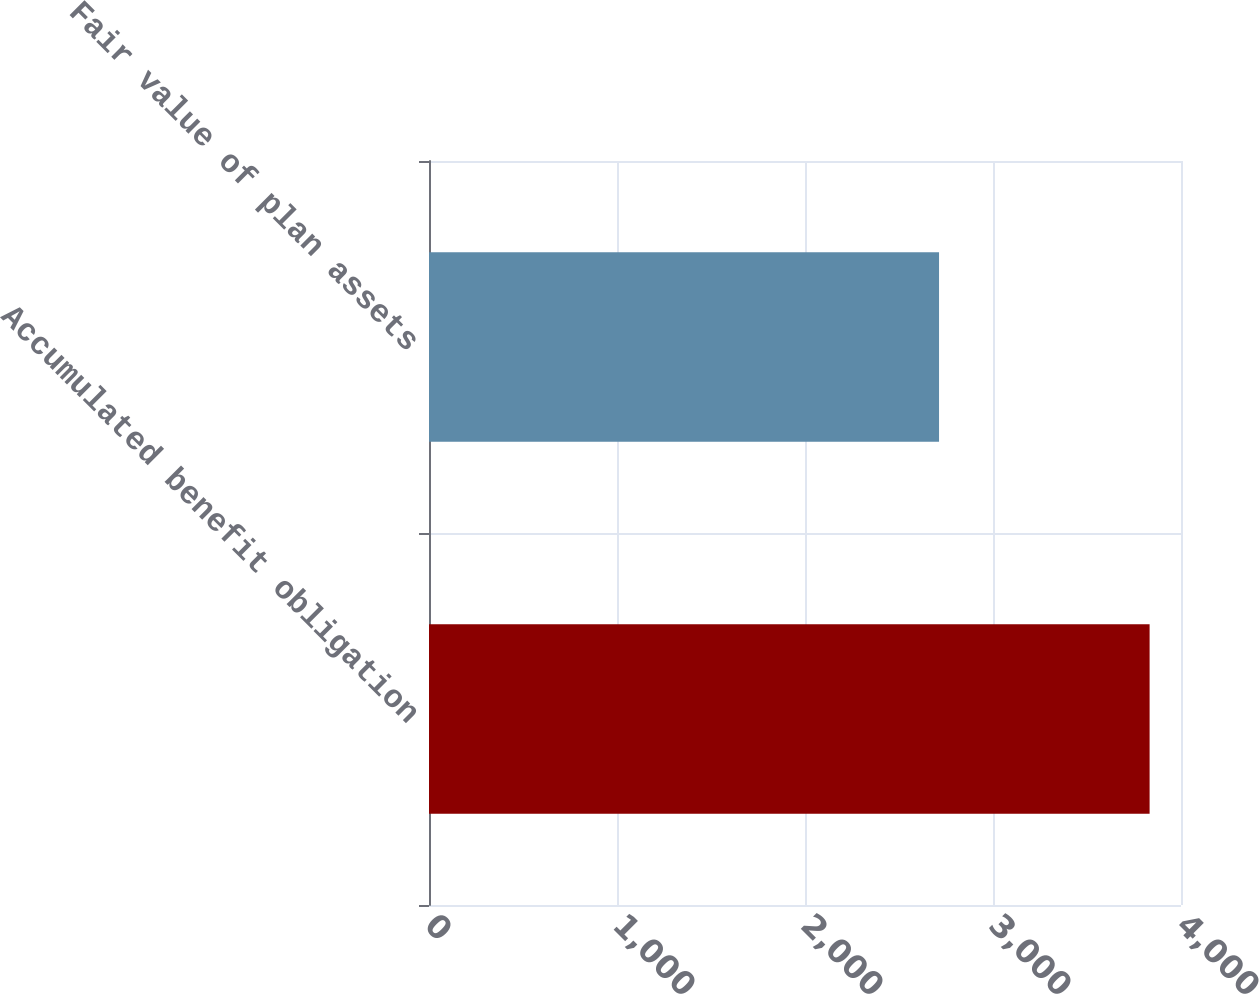Convert chart. <chart><loc_0><loc_0><loc_500><loc_500><bar_chart><fcel>Accumulated benefit obligation<fcel>Fair value of plan assets<nl><fcel>3833<fcel>2713<nl></chart> 